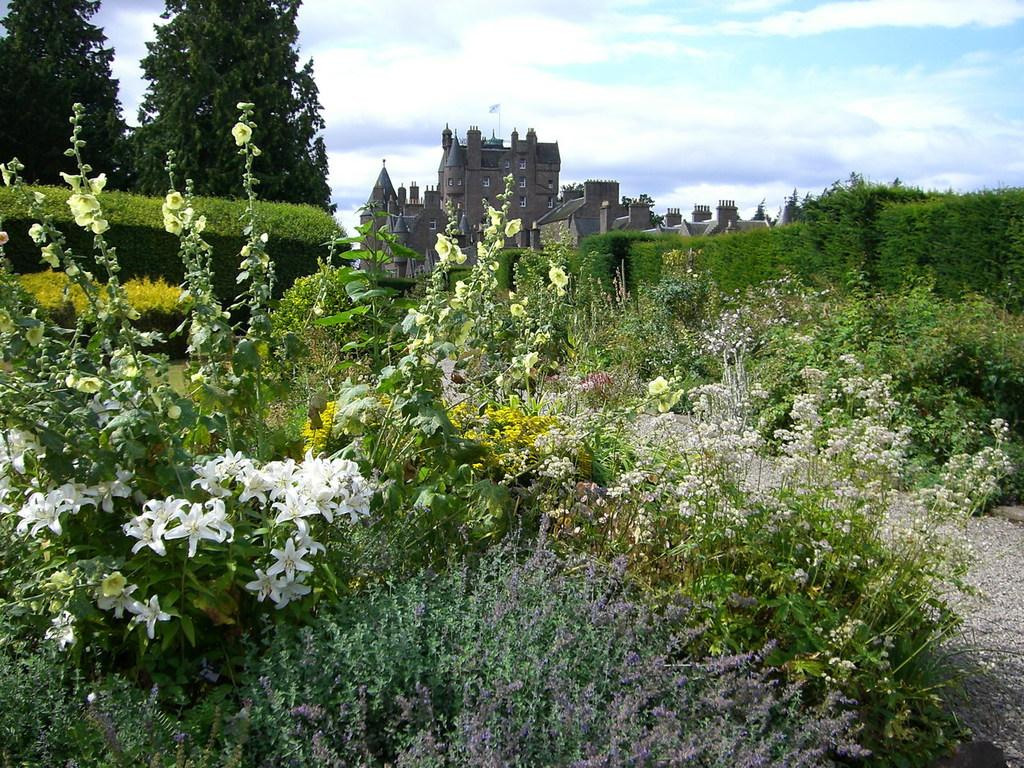What type of living organisms can be seen in the image? Plants, including white and yellow flowers, bushes, and trees, can be seen in the image. What structures are visible in the background of the image? There is a building and a flag in the background of the image. What can be seen in the sky in the image? Clouds and the sky are visible in the background of the image. How many bears are climbing the trees in the image? There are no bears present in the image; it features plants, flowers, bushes, trees, a building, a flag, clouds, and the sky. What type of knot is used to secure the flag in the image? There is no knot visible in the image, as the focus is on the plants and the flag in the background. 